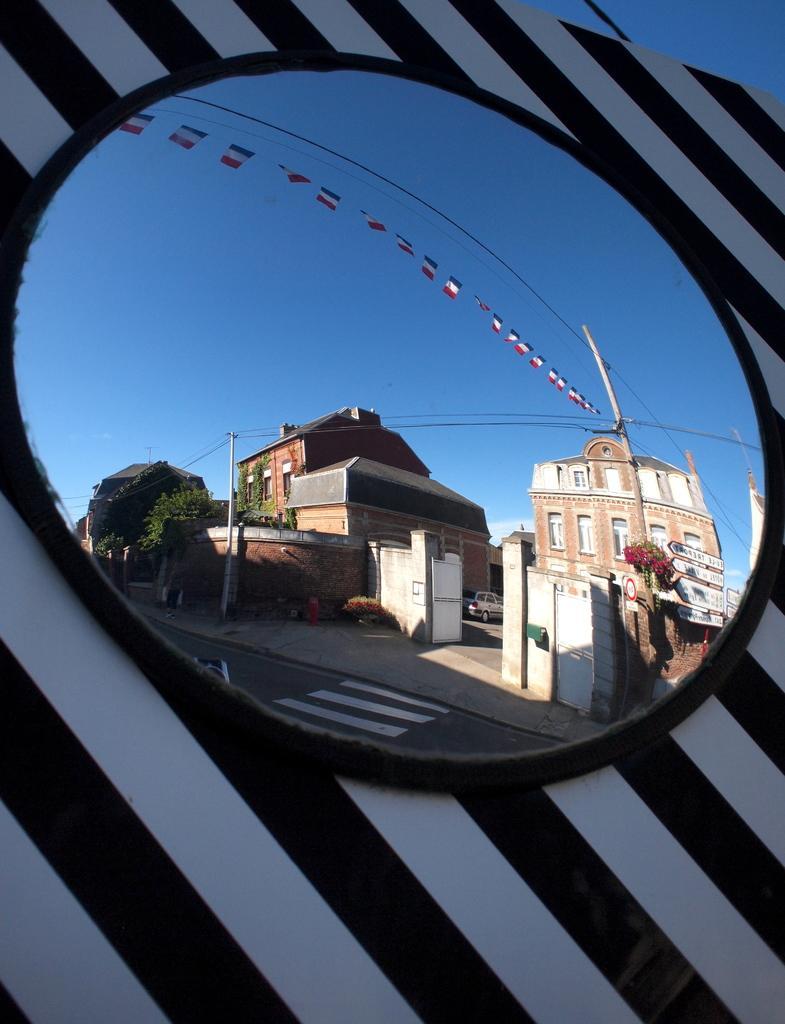Could you give a brief overview of what you see in this image? In this image there is a mirror on the wall through which we can see road, current poles, trees, buildings, car and sky. 